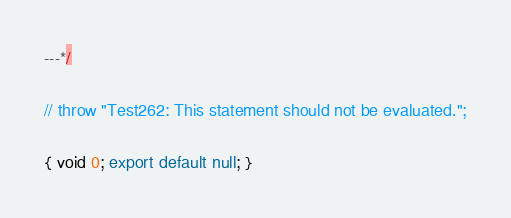Convert code to text. <code><loc_0><loc_0><loc_500><loc_500><_JavaScript_>---*/

// throw "Test262: This statement should not be evaluated.";

{ void 0; export default null; }
</code> 